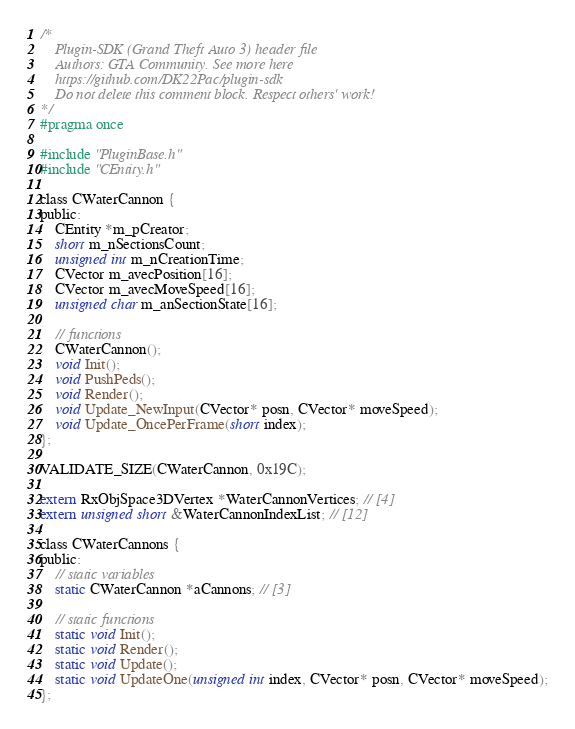<code> <loc_0><loc_0><loc_500><loc_500><_C_>/*
    Plugin-SDK (Grand Theft Auto 3) header file
    Authors: GTA Community. See more here
    https://github.com/DK22Pac/plugin-sdk
    Do not delete this comment block. Respect others' work!
*/
#pragma once

#include "PluginBase.h"
#include "CEntity.h"

class CWaterCannon {
public:
    CEntity *m_pCreator;
    short m_nSectionsCount;
    unsigned int m_nCreationTime;
    CVector m_avecPosition[16];
    CVector m_avecMoveSpeed[16];
    unsigned char m_anSectionState[16];

    // functions
    CWaterCannon();
    void Init();
    void PushPeds();
    void Render();
    void Update_NewInput(CVector* posn, CVector* moveSpeed);
    void Update_OncePerFrame(short index);
};

VALIDATE_SIZE(CWaterCannon, 0x19C);

extern RxObjSpace3DVertex *WaterCannonVertices; // [4]
extern unsigned short &WaterCannonIndexList; // [12]

class CWaterCannons {
public:
    // static variables
    static CWaterCannon *aCannons; // [3]

    // static functions
    static void Init();
    static void Render();
    static void Update();
    static void UpdateOne(unsigned int index, CVector* posn, CVector* moveSpeed);
};
</code> 